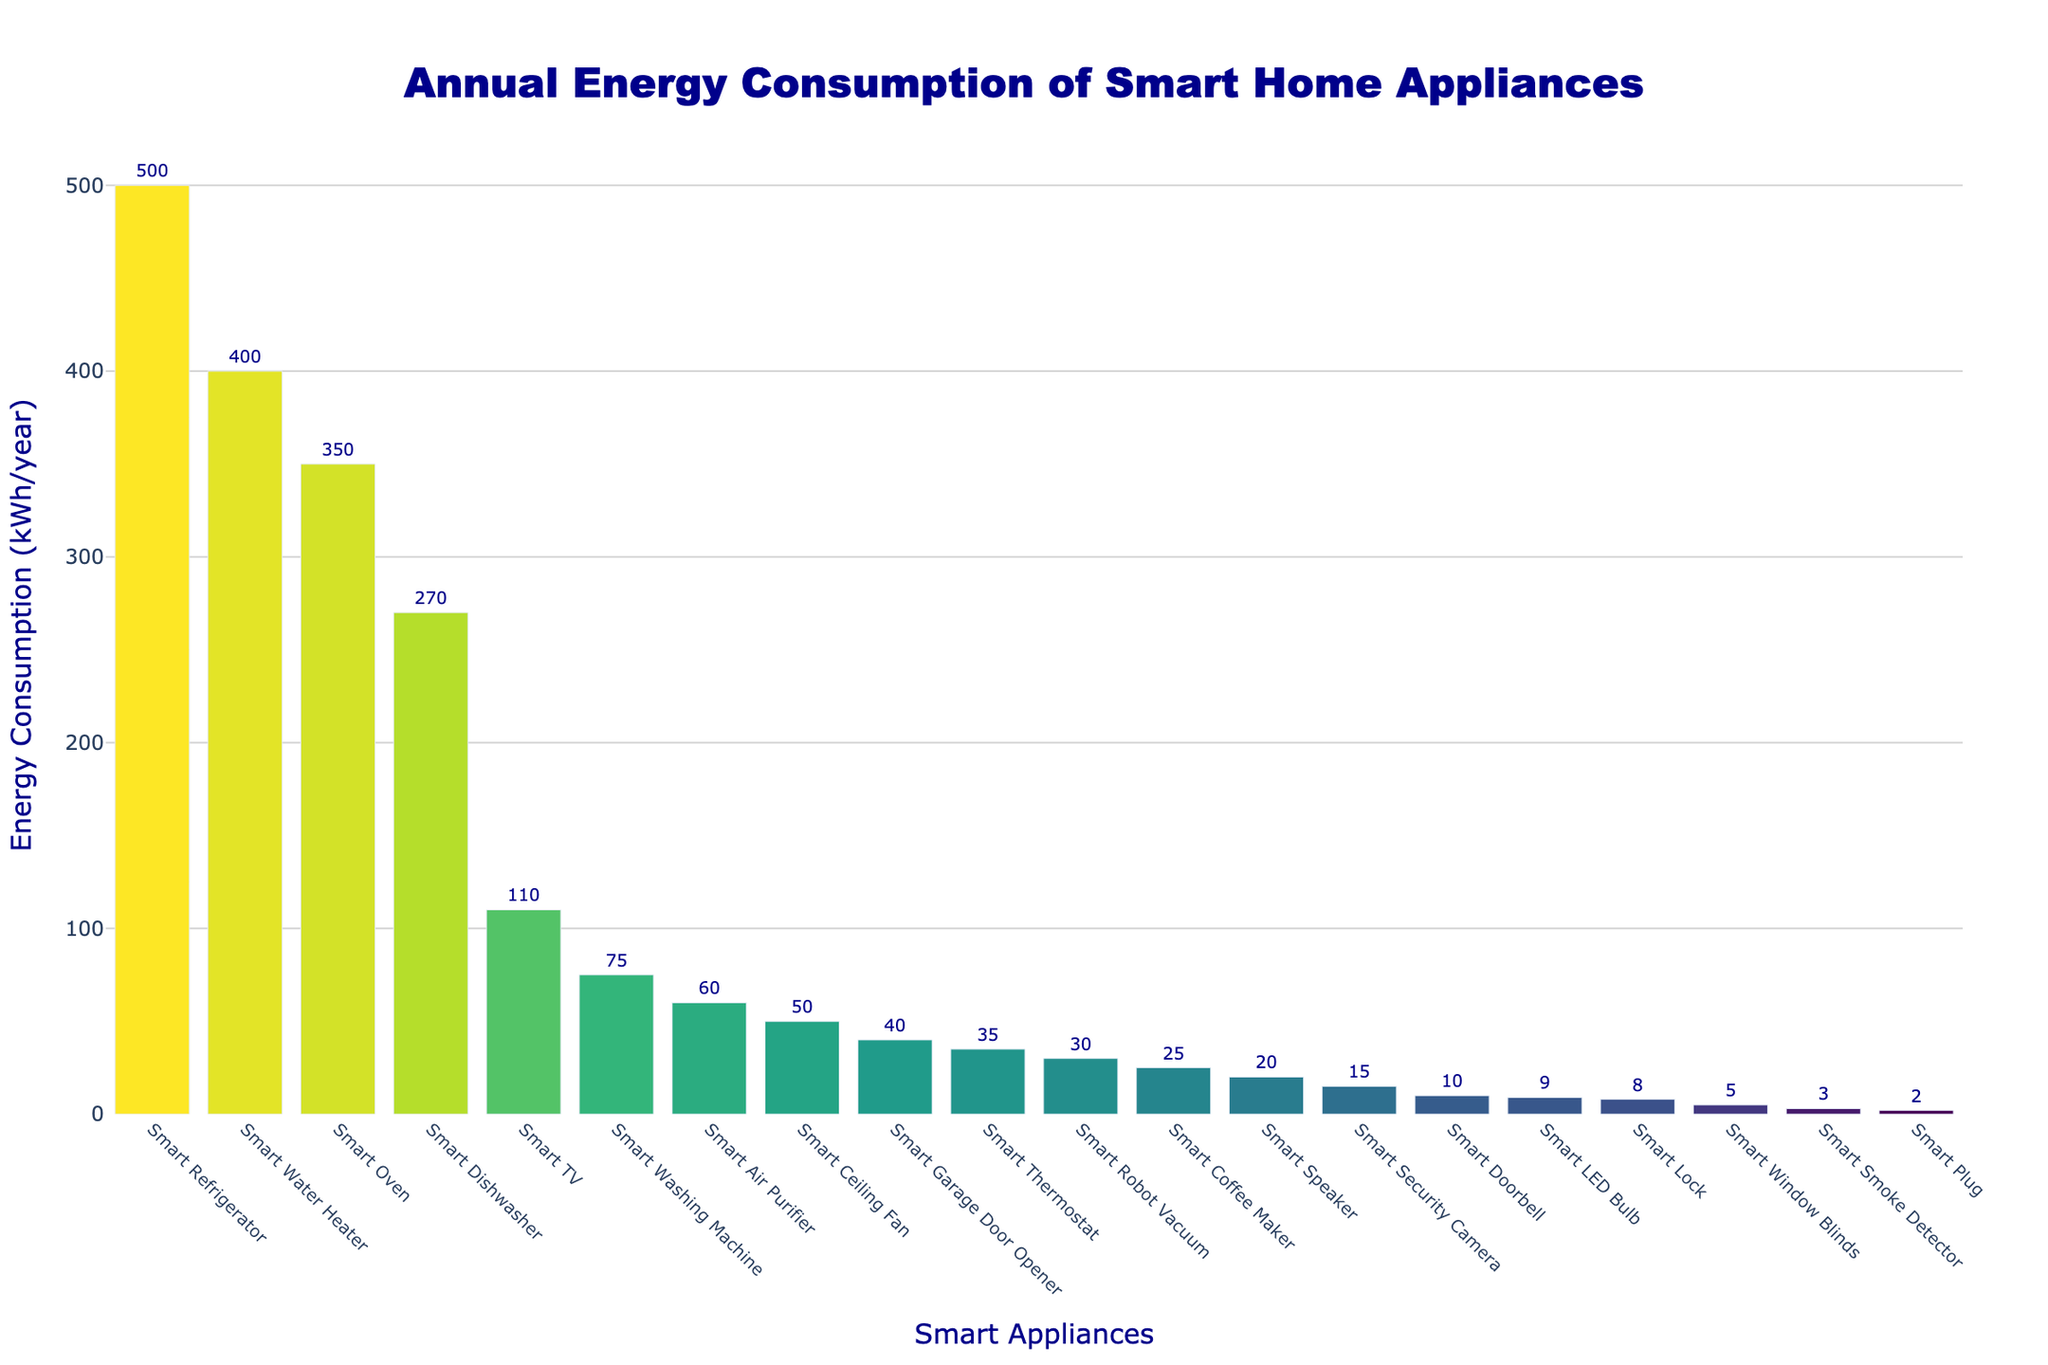What's the appliance with the highest energy consumption? The bar for the Smart Refrigerator is the tallest, indicating it has the highest energy consumption.
Answer: Smart Refrigerator What is the total energy consumption of Smart Thermostat, Smart LED Bulb, and Smart Plug? Add the energy consumption of Smart Thermostat (35 kWh/year), Smart LED Bulb (9 kWh/year), and Smart Plug (2 kWh/year): 35 + 9 + 2 = 46.
Answer: 46 kWh/year Which appliance consumes more energy: Smart Oven or Smart Air Purifier? Compare the heights of the bars for Smart Oven and Smart Air Purifier; Smart Oven has a taller bar.
Answer: Smart Oven What is the difference in energy consumption between the Smart TV and the Smart Dishwasher? The energy consumption of Smart TV is 110 kWh/year and for Smart Dishwasher is 270 kWh/year. The difference is 270 - 110 = 160.
Answer: 160 kWh/year Which appliance has a lower energy consumption: Smart Lock or Smart Smoke Detector? Compare the heights of the bars for Smart Lock and Smart Smoke Detector; Smart Smoke Detector has a shorter bar.
Answer: Smart Smoke Detector What is the average energy consumption of Smart Oven, Smart Water Heater, and Smart Refrigerator? Add the energy consumption (350 kWh/year for Smart Oven, 400 kWh/year for Smart Water Heater, 500 kWh/year for Smart Refrigerator) and divide by 3: (350 + 400 + 500) / 3 = 1250 / 3 ≈ 416.67.
Answer: 416.67 kWh/year Which appliances' bars are colored more toward the lighter end of the spectrum and what's the reason? The bars towards the left (like Smart Refrigerator, Smart Oven, etc.) are lighter in color due to the logarithmic color scale representing higher energy consumption ranges.
Answer: High-energy consuming appliances How many appliances consume less than 50 kWh/year annually? Identify the appliances with bars shorter than 50 kWh/year: Smart Thermostat, Smart LED Bulb, Smart Plug, Smart Speaker, Smart Doorbell, Smart Security Camera, Smart Smoke Detector, Smart Lock, Smart Robot Vacuum, Smart Coffee Maker, Smart Ceiling Fan, Smart Garage Door Opener, Smart Window Blinds. Count them: 13.
Answer: 13 What is the combined energy consumption of all appliances? Sum up the energy consumption values for all appliances: 35 + 9 + 2 + 20 + 500 + 75 + 270 + 110 + 10 + 15 + 350 + 60 + 30 + 400 + 25 + 50 + 40 + 5 + 3 + 8 = 2017.
Answer: 2017 kWh/year 